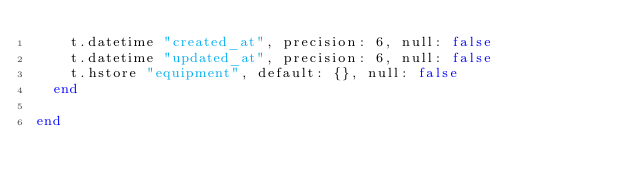Convert code to text. <code><loc_0><loc_0><loc_500><loc_500><_Ruby_>    t.datetime "created_at", precision: 6, null: false
    t.datetime "updated_at", precision: 6, null: false
    t.hstore "equipment", default: {}, null: false
  end

end
</code> 